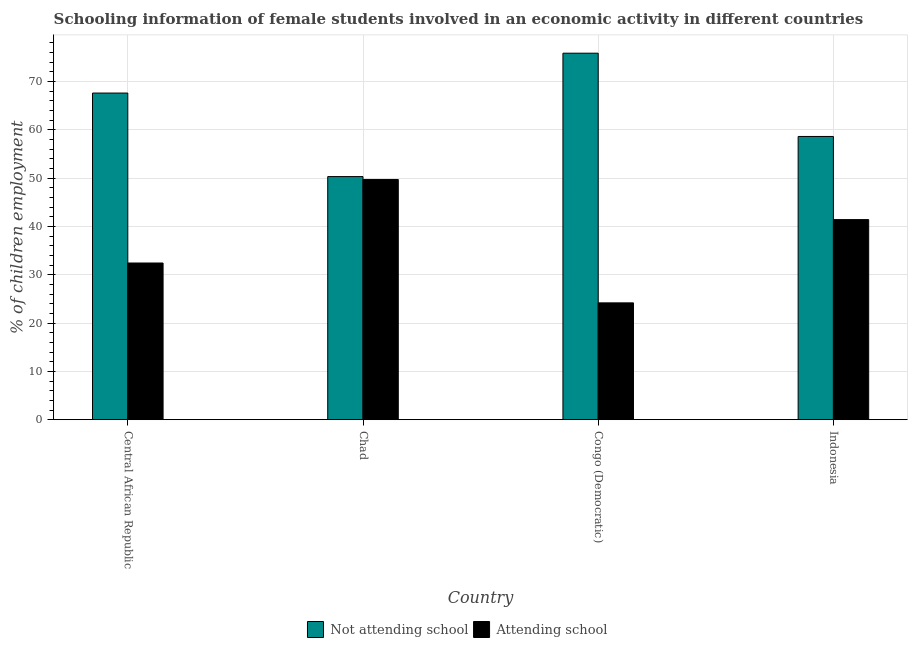How many different coloured bars are there?
Give a very brief answer. 2. How many groups of bars are there?
Keep it short and to the point. 4. Are the number of bars on each tick of the X-axis equal?
Your answer should be compact. Yes. How many bars are there on the 2nd tick from the right?
Ensure brevity in your answer.  2. What is the label of the 4th group of bars from the left?
Your response must be concise. Indonesia. In how many cases, is the number of bars for a given country not equal to the number of legend labels?
Your response must be concise. 0. What is the percentage of employed females who are not attending school in Indonesia?
Offer a very short reply. 58.6. Across all countries, what is the maximum percentage of employed females who are not attending school?
Provide a succinct answer. 75.83. Across all countries, what is the minimum percentage of employed females who are attending school?
Make the answer very short. 24.17. In which country was the percentage of employed females who are attending school maximum?
Your answer should be very brief. Chad. In which country was the percentage of employed females who are attending school minimum?
Your answer should be compact. Congo (Democratic). What is the total percentage of employed females who are not attending school in the graph?
Ensure brevity in your answer.  252.31. What is the difference between the percentage of employed females who are attending school in Congo (Democratic) and that in Indonesia?
Offer a very short reply. -17.23. What is the difference between the percentage of employed females who are attending school in Central African Republic and the percentage of employed females who are not attending school in Congo (Democratic)?
Provide a short and direct response. -43.41. What is the average percentage of employed females who are attending school per country?
Offer a terse response. 36.92. What is the difference between the percentage of employed females who are attending school and percentage of employed females who are not attending school in Indonesia?
Provide a short and direct response. -17.2. In how many countries, is the percentage of employed females who are not attending school greater than 38 %?
Offer a very short reply. 4. What is the ratio of the percentage of employed females who are not attending school in Chad to that in Indonesia?
Provide a succinct answer. 0.86. Is the percentage of employed females who are attending school in Chad less than that in Indonesia?
Keep it short and to the point. No. Is the difference between the percentage of employed females who are attending school in Chad and Congo (Democratic) greater than the difference between the percentage of employed females who are not attending school in Chad and Congo (Democratic)?
Give a very brief answer. Yes. What is the difference between the highest and the second highest percentage of employed females who are attending school?
Give a very brief answer. 8.3. What is the difference between the highest and the lowest percentage of employed females who are attending school?
Give a very brief answer. 25.53. In how many countries, is the percentage of employed females who are attending school greater than the average percentage of employed females who are attending school taken over all countries?
Your response must be concise. 2. Is the sum of the percentage of employed females who are attending school in Central African Republic and Congo (Democratic) greater than the maximum percentage of employed females who are not attending school across all countries?
Provide a short and direct response. No. What does the 1st bar from the left in Chad represents?
Your response must be concise. Not attending school. What does the 1st bar from the right in Central African Republic represents?
Provide a succinct answer. Attending school. How many countries are there in the graph?
Make the answer very short. 4. What is the difference between two consecutive major ticks on the Y-axis?
Give a very brief answer. 10. Does the graph contain any zero values?
Offer a very short reply. No. How many legend labels are there?
Offer a very short reply. 2. How are the legend labels stacked?
Offer a terse response. Horizontal. What is the title of the graph?
Give a very brief answer. Schooling information of female students involved in an economic activity in different countries. Does "Fixed telephone" appear as one of the legend labels in the graph?
Your response must be concise. No. What is the label or title of the X-axis?
Your response must be concise. Country. What is the label or title of the Y-axis?
Give a very brief answer. % of children employment. What is the % of children employment of Not attending school in Central African Republic?
Provide a succinct answer. 67.58. What is the % of children employment in Attending school in Central African Republic?
Provide a short and direct response. 32.42. What is the % of children employment of Not attending school in Chad?
Offer a terse response. 50.3. What is the % of children employment in Attending school in Chad?
Provide a short and direct response. 49.7. What is the % of children employment in Not attending school in Congo (Democratic)?
Give a very brief answer. 75.83. What is the % of children employment in Attending school in Congo (Democratic)?
Give a very brief answer. 24.17. What is the % of children employment of Not attending school in Indonesia?
Your answer should be compact. 58.6. What is the % of children employment of Attending school in Indonesia?
Keep it short and to the point. 41.4. Across all countries, what is the maximum % of children employment of Not attending school?
Offer a very short reply. 75.83. Across all countries, what is the maximum % of children employment in Attending school?
Provide a short and direct response. 49.7. Across all countries, what is the minimum % of children employment in Not attending school?
Offer a terse response. 50.3. Across all countries, what is the minimum % of children employment in Attending school?
Your answer should be compact. 24.17. What is the total % of children employment of Not attending school in the graph?
Provide a succinct answer. 252.31. What is the total % of children employment of Attending school in the graph?
Offer a terse response. 147.69. What is the difference between the % of children employment of Not attending school in Central African Republic and that in Chad?
Make the answer very short. 17.28. What is the difference between the % of children employment in Attending school in Central African Republic and that in Chad?
Ensure brevity in your answer.  -17.28. What is the difference between the % of children employment in Not attending school in Central African Republic and that in Congo (Democratic)?
Offer a very short reply. -8.25. What is the difference between the % of children employment of Attending school in Central African Republic and that in Congo (Democratic)?
Offer a very short reply. 8.25. What is the difference between the % of children employment in Not attending school in Central African Republic and that in Indonesia?
Make the answer very short. 8.98. What is the difference between the % of children employment of Attending school in Central African Republic and that in Indonesia?
Ensure brevity in your answer.  -8.98. What is the difference between the % of children employment of Not attending school in Chad and that in Congo (Democratic)?
Your response must be concise. -25.53. What is the difference between the % of children employment in Attending school in Chad and that in Congo (Democratic)?
Provide a short and direct response. 25.53. What is the difference between the % of children employment of Not attending school in Chad and that in Indonesia?
Provide a succinct answer. -8.3. What is the difference between the % of children employment in Attending school in Chad and that in Indonesia?
Offer a terse response. 8.3. What is the difference between the % of children employment of Not attending school in Congo (Democratic) and that in Indonesia?
Keep it short and to the point. 17.23. What is the difference between the % of children employment of Attending school in Congo (Democratic) and that in Indonesia?
Provide a succinct answer. -17.23. What is the difference between the % of children employment of Not attending school in Central African Republic and the % of children employment of Attending school in Chad?
Your response must be concise. 17.88. What is the difference between the % of children employment in Not attending school in Central African Republic and the % of children employment in Attending school in Congo (Democratic)?
Provide a succinct answer. 43.41. What is the difference between the % of children employment of Not attending school in Central African Republic and the % of children employment of Attending school in Indonesia?
Your answer should be very brief. 26.18. What is the difference between the % of children employment of Not attending school in Chad and the % of children employment of Attending school in Congo (Democratic)?
Keep it short and to the point. 26.13. What is the difference between the % of children employment of Not attending school in Congo (Democratic) and the % of children employment of Attending school in Indonesia?
Offer a very short reply. 34.43. What is the average % of children employment of Not attending school per country?
Keep it short and to the point. 63.08. What is the average % of children employment in Attending school per country?
Your answer should be very brief. 36.92. What is the difference between the % of children employment in Not attending school and % of children employment in Attending school in Central African Republic?
Ensure brevity in your answer.  35.16. What is the difference between the % of children employment of Not attending school and % of children employment of Attending school in Congo (Democratic)?
Ensure brevity in your answer.  51.66. What is the ratio of the % of children employment in Not attending school in Central African Republic to that in Chad?
Offer a terse response. 1.34. What is the ratio of the % of children employment of Attending school in Central African Republic to that in Chad?
Give a very brief answer. 0.65. What is the ratio of the % of children employment of Not attending school in Central African Republic to that in Congo (Democratic)?
Give a very brief answer. 0.89. What is the ratio of the % of children employment in Attending school in Central African Republic to that in Congo (Democratic)?
Provide a succinct answer. 1.34. What is the ratio of the % of children employment in Not attending school in Central African Republic to that in Indonesia?
Make the answer very short. 1.15. What is the ratio of the % of children employment in Attending school in Central African Republic to that in Indonesia?
Keep it short and to the point. 0.78. What is the ratio of the % of children employment in Not attending school in Chad to that in Congo (Democratic)?
Make the answer very short. 0.66. What is the ratio of the % of children employment of Attending school in Chad to that in Congo (Democratic)?
Provide a succinct answer. 2.06. What is the ratio of the % of children employment in Not attending school in Chad to that in Indonesia?
Give a very brief answer. 0.86. What is the ratio of the % of children employment of Attending school in Chad to that in Indonesia?
Provide a succinct answer. 1.2. What is the ratio of the % of children employment in Not attending school in Congo (Democratic) to that in Indonesia?
Provide a short and direct response. 1.29. What is the ratio of the % of children employment of Attending school in Congo (Democratic) to that in Indonesia?
Ensure brevity in your answer.  0.58. What is the difference between the highest and the second highest % of children employment of Not attending school?
Your answer should be very brief. 8.25. What is the difference between the highest and the second highest % of children employment in Attending school?
Give a very brief answer. 8.3. What is the difference between the highest and the lowest % of children employment of Not attending school?
Offer a terse response. 25.53. What is the difference between the highest and the lowest % of children employment of Attending school?
Your answer should be compact. 25.53. 